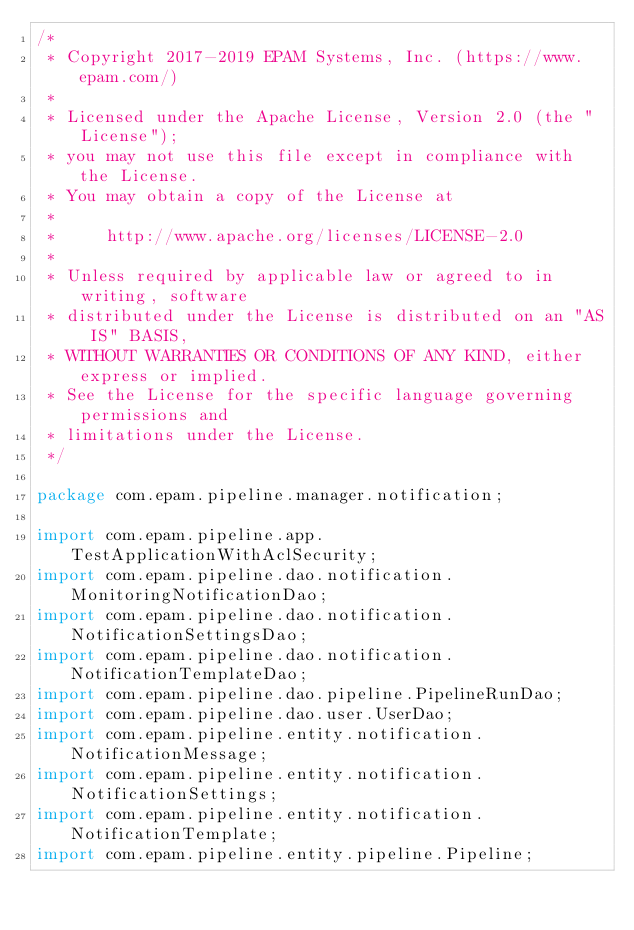Convert code to text. <code><loc_0><loc_0><loc_500><loc_500><_Java_>/*
 * Copyright 2017-2019 EPAM Systems, Inc. (https://www.epam.com/)
 *
 * Licensed under the Apache License, Version 2.0 (the "License");
 * you may not use this file except in compliance with the License.
 * You may obtain a copy of the License at
 *
 *     http://www.apache.org/licenses/LICENSE-2.0
 *
 * Unless required by applicable law or agreed to in writing, software
 * distributed under the License is distributed on an "AS IS" BASIS,
 * WITHOUT WARRANTIES OR CONDITIONS OF ANY KIND, either express or implied.
 * See the License for the specific language governing permissions and
 * limitations under the License.
 */

package com.epam.pipeline.manager.notification;

import com.epam.pipeline.app.TestApplicationWithAclSecurity;
import com.epam.pipeline.dao.notification.MonitoringNotificationDao;
import com.epam.pipeline.dao.notification.NotificationSettingsDao;
import com.epam.pipeline.dao.notification.NotificationTemplateDao;
import com.epam.pipeline.dao.pipeline.PipelineRunDao;
import com.epam.pipeline.dao.user.UserDao;
import com.epam.pipeline.entity.notification.NotificationMessage;
import com.epam.pipeline.entity.notification.NotificationSettings;
import com.epam.pipeline.entity.notification.NotificationTemplate;
import com.epam.pipeline.entity.pipeline.Pipeline;</code> 